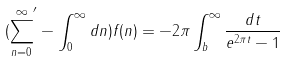<formula> <loc_0><loc_0><loc_500><loc_500>( { \sum _ { n = 0 } ^ { \infty } } ^ { \prime } - \int _ { 0 } ^ { \infty } d n ) f ( n ) = - 2 \pi \int _ { b } ^ { \infty } \frac { d t } { e ^ { 2 \pi t } - 1 }</formula> 